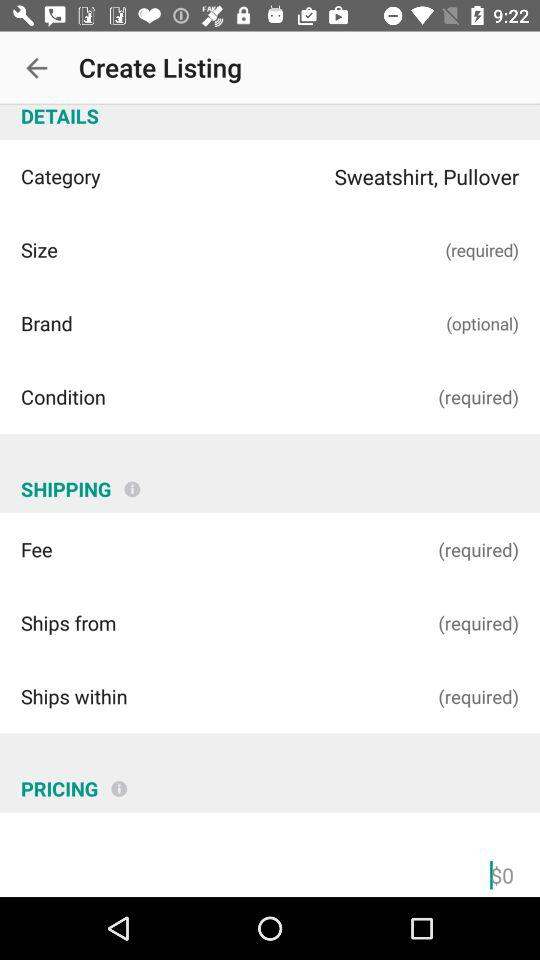How many required fields are in the shipping section?
Answer the question using a single word or phrase. 3 